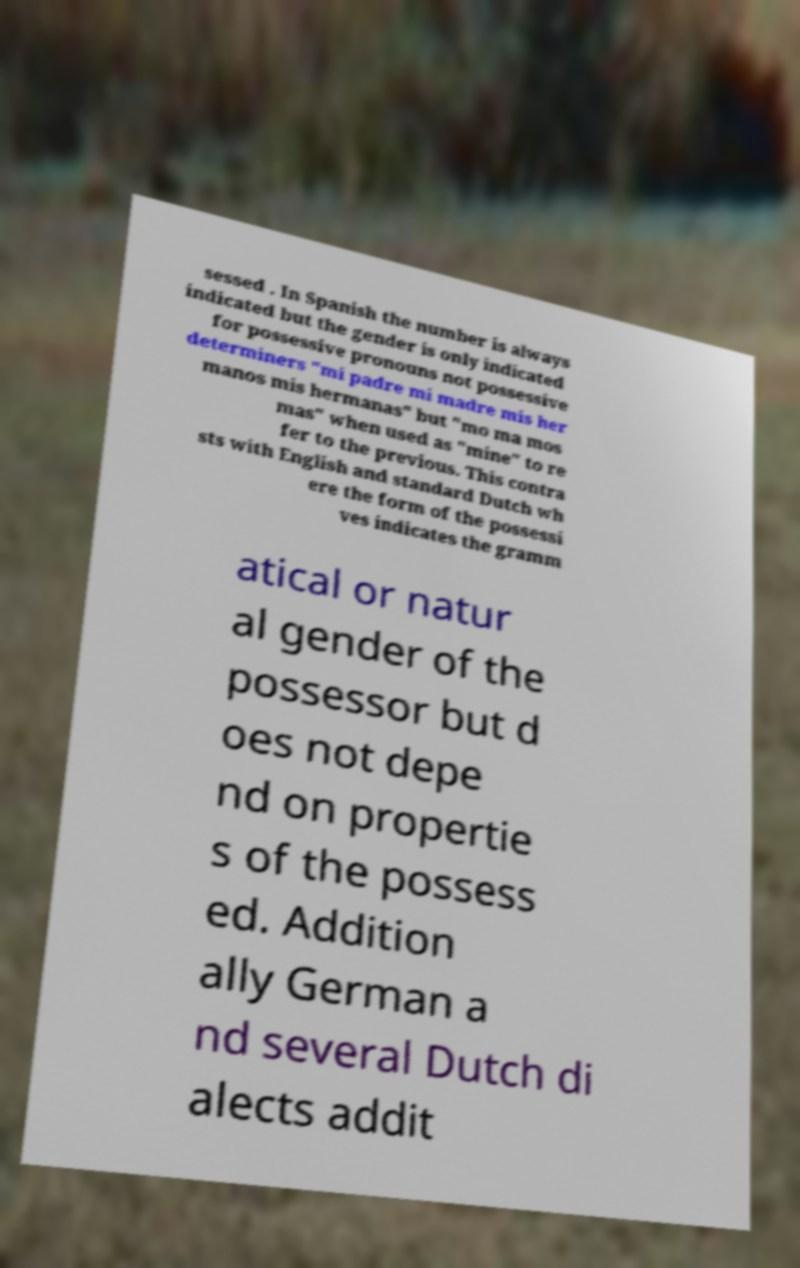Could you extract and type out the text from this image? sessed . In Spanish the number is always indicated but the gender is only indicated for possessive pronouns not possessive determiners "mi padre mi madre mis her manos mis hermanas" but "mo ma mos mas" when used as "mine" to re fer to the previous. This contra sts with English and standard Dutch wh ere the form of the possessi ves indicates the gramm atical or natur al gender of the possessor but d oes not depe nd on propertie s of the possess ed. Addition ally German a nd several Dutch di alects addit 